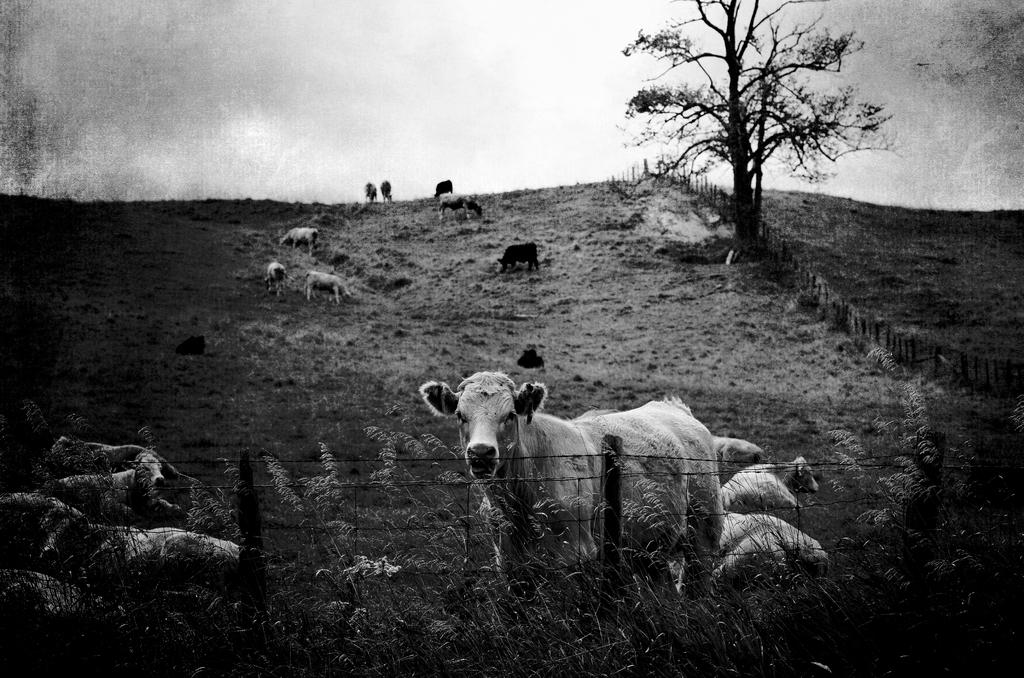What types of living organisms can be seen in the image? There are animals in the image. What is the barrier that separates the animals from the surrounding area? There is a fence in the image. What type of vegetation is visible in the image? There is grass visible in the image. What can be seen in the background of the image? There is a tree and the sky visible in the background of the image. What type of board is being used to support the planes in the image? There are no planes or boards present in the image. 